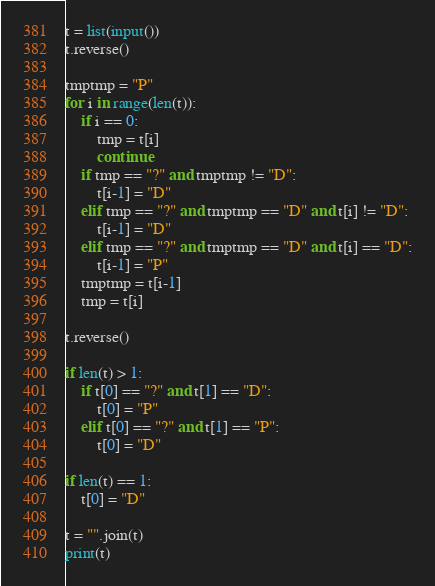Convert code to text. <code><loc_0><loc_0><loc_500><loc_500><_Python_>t = list(input())
t.reverse()

tmptmp = "P"
for i in range(len(t)):
    if i == 0:
        tmp = t[i]
        continue
    if tmp == "?" and tmptmp != "D":
        t[i-1] = "D"
    elif tmp == "?" and tmptmp == "D" and t[i] != "D":
        t[i-1] = "D"
    elif tmp == "?" and tmptmp == "D" and t[i] == "D":
        t[i-1] = "P"
    tmptmp = t[i-1]
    tmp = t[i]

t.reverse()

if len(t) > 1:
    if t[0] == "?" and t[1] == "D":
        t[0] = "P"
    elif t[0] == "?" and t[1] == "P":
        t[0] = "D"

if len(t) == 1:
    t[0] = "D"

t = "".join(t)
print(t)
</code> 